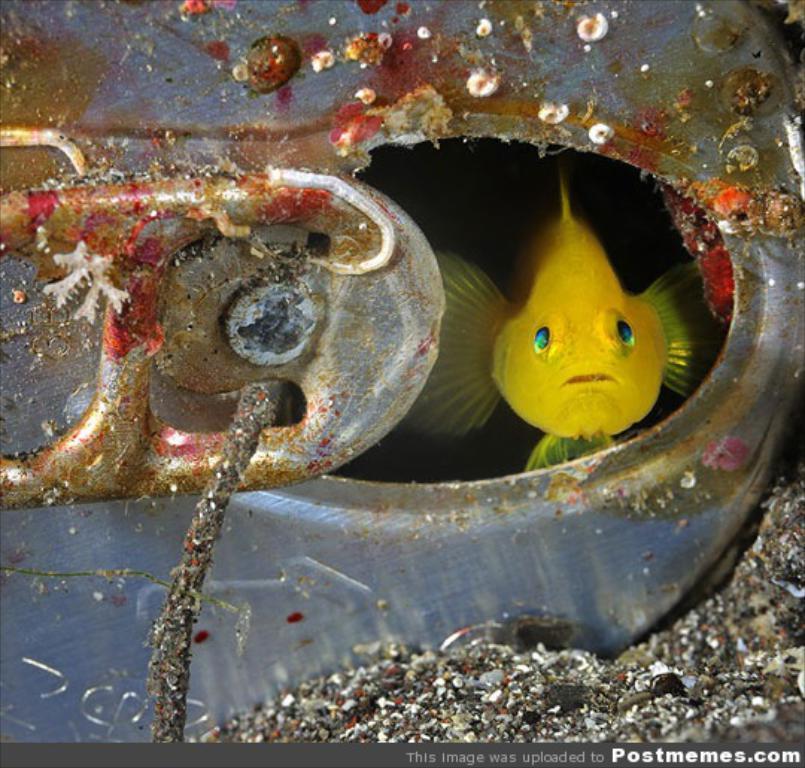In one or two sentences, can you explain what this image depicts? In this image we can see a fish which is yellow in color. 